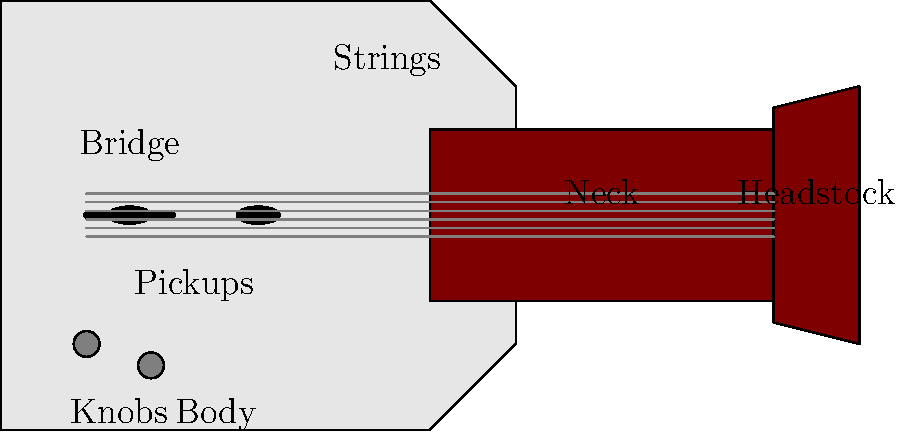As a small town general news reporter covering a local music festival, you've been asked to write an article about electric guitars. Which part of the electric guitar is responsible for converting the vibration of the strings into electrical signals? To answer this question, let's break down the main parts of an electric guitar and their functions:

1. Body: The main part of the guitar that supports all other components.
2. Neck: The long, narrow part extending from the body, where the strings are pressed to create different notes.
3. Headstock: The end of the neck, where the tuning pegs are located.
4. Bridge: Holds the strings in place and transfers their vibration to the body.
5. Strings: The vibrating elements that produce the sound.
6. Knobs: Control various aspects of the guitar's sound, such as volume and tone.
7. Pickups: These are the key components we're looking for in this question.

The pickups are electromagnetic devices that convert the mechanical vibration of the strings into electrical signals. They work on the principle of electromagnetic induction:

1. The pickups contain magnets wrapped with wire coils.
2. When a metal string vibrates above the pickup, it disturbs the magnetic field.
3. This disturbance induces a small electrical current in the wire coils.
4. This electrical signal is then sent to an amplifier, which increases its strength and sends it to speakers.

Therefore, the pickups are the crucial component that allows an electric guitar to produce an amplified sound, converting the physical vibration of the strings into an electrical signal that can be processed and amplified.
Answer: Pickups 